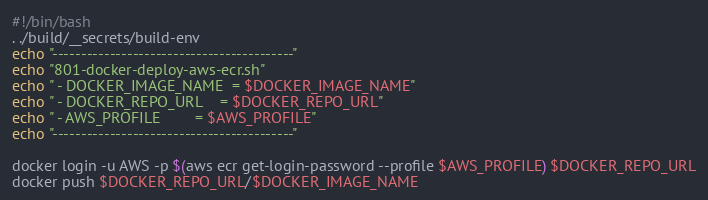Convert code to text. <code><loc_0><loc_0><loc_500><loc_500><_Bash_>#!/bin/bash
. ./build/__secrets/build-env
echo "------------------------------------------"
echo "801-docker-deploy-aws-ecr.sh"
echo " - DOCKER_IMAGE_NAME  = $DOCKER_IMAGE_NAME"
echo " - DOCKER_REPO_URL    = $DOCKER_REPO_URL"
echo " - AWS_PROFILE        = $AWS_PROFILE"
echo "------------------------------------------"

docker login -u AWS -p $(aws ecr get-login-password --profile $AWS_PROFILE) $DOCKER_REPO_URL
docker push $DOCKER_REPO_URL/$DOCKER_IMAGE_NAME
</code> 